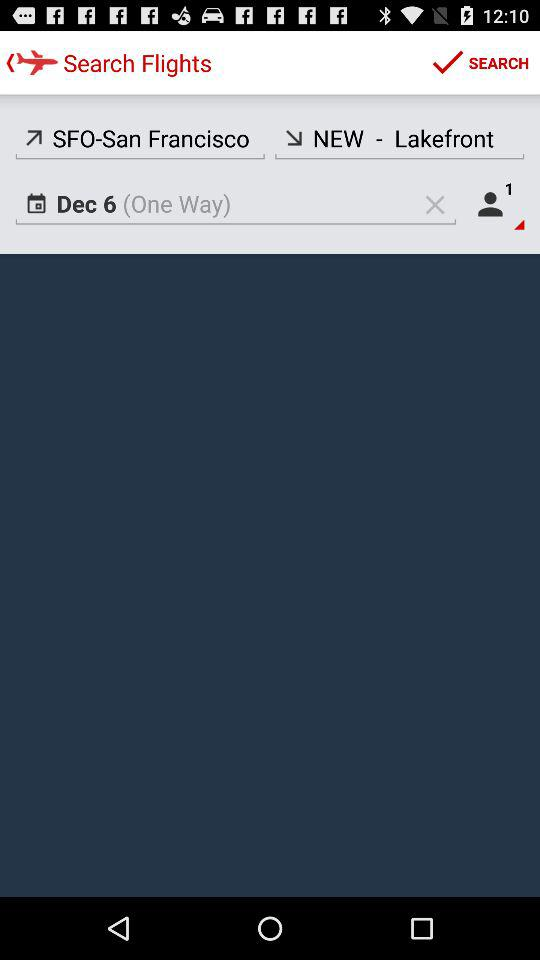How many people are traveling?
Answer the question using a single word or phrase. 1 